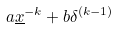Convert formula to latex. <formula><loc_0><loc_0><loc_500><loc_500>a \underline { x } ^ { - k } + b \delta ^ { ( k - 1 ) }</formula> 